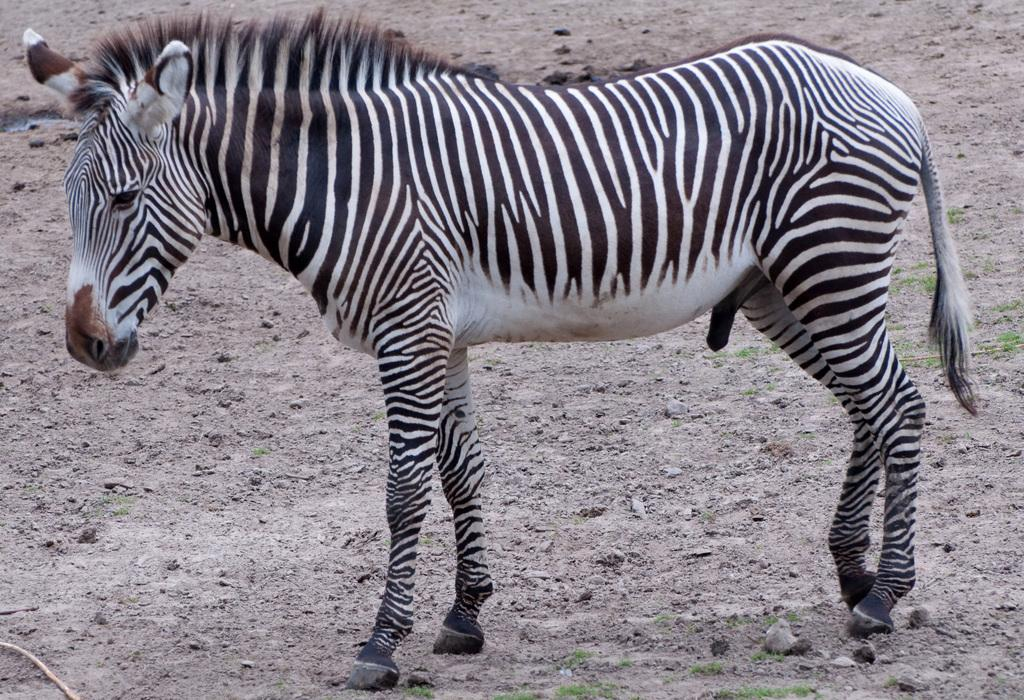What animal is present in the image? There is a zebra in the image. What is the zebra doing in the image? The zebra is standing on the ground. What color pattern does the zebra have? The zebra has black and white stripes. What can be seen in the background of the image? The background of the image includes the ground. What type of bead is the zebra holding in its mouth in the image? There is no bead present in the image; the zebra is not holding anything in its mouth. What does the zebra's mom look like in the image? There is no mention of the zebra's mom in the image, and the zebra is not accompanied by any other animals. 